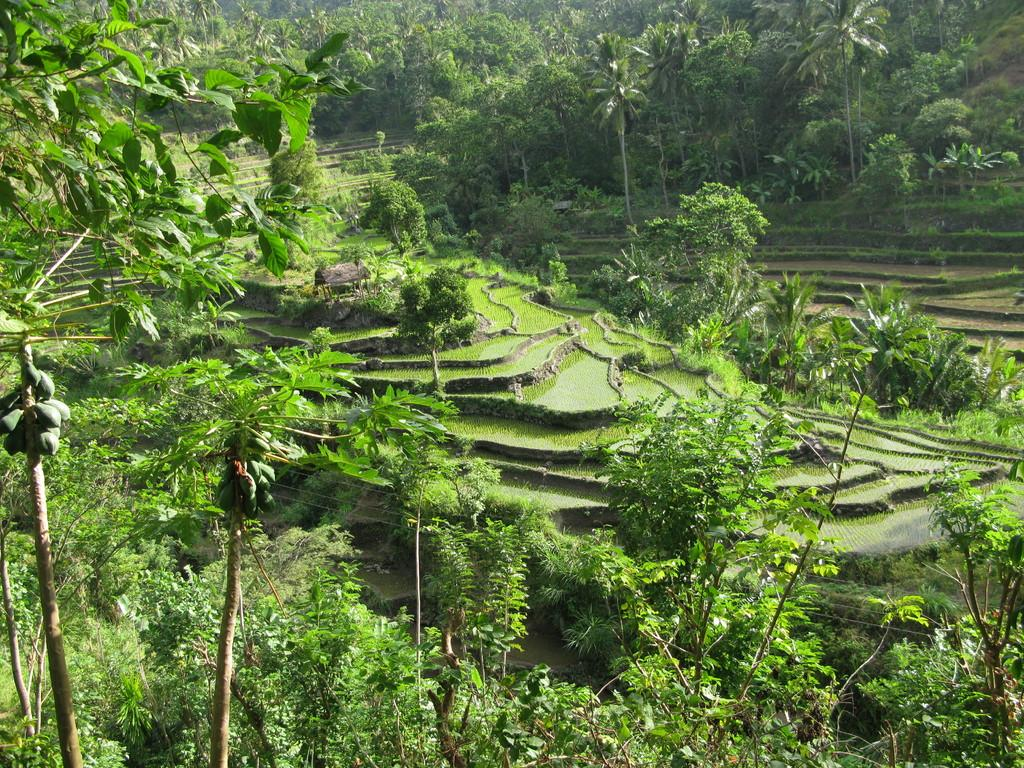What type of vegetation can be seen in the image? There are trees in the image. What type of landscape is visible in the image? There are fields in the image. What type of root can be seen growing from the trees in the image? There is no root visible in the image; only the trees themselves are present. What breed of dog can be seen playing in the fields in the image? There are no dogs present in the image; it only features trees and fields. 